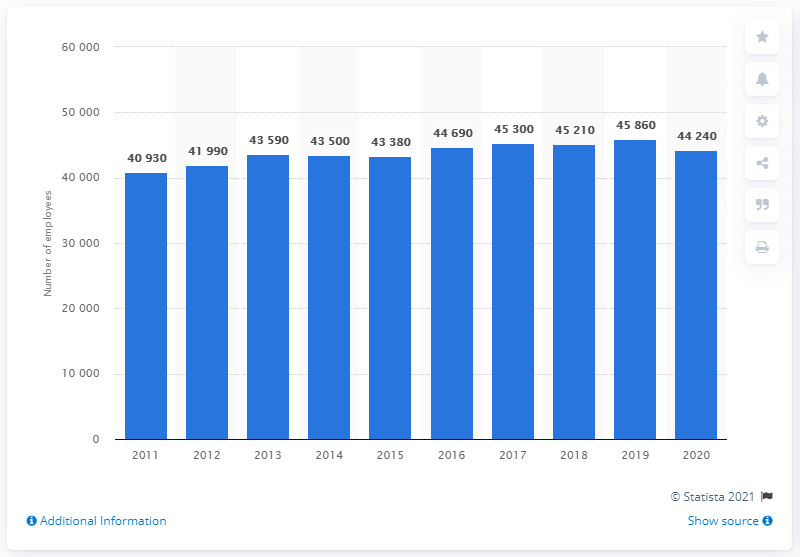Mention a couple of crucial points in this snapshot. In 2020, an estimated 44,240 writers and authors were actively working in the United States. 